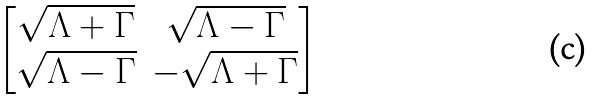Convert formula to latex. <formula><loc_0><loc_0><loc_500><loc_500>\begin{bmatrix} \sqrt { \Lambda + \Gamma } & \sqrt { \Lambda - \Gamma } \\ \sqrt { \Lambda - \Gamma } & - \sqrt { \Lambda + \Gamma } \\ \end{bmatrix}</formula> 